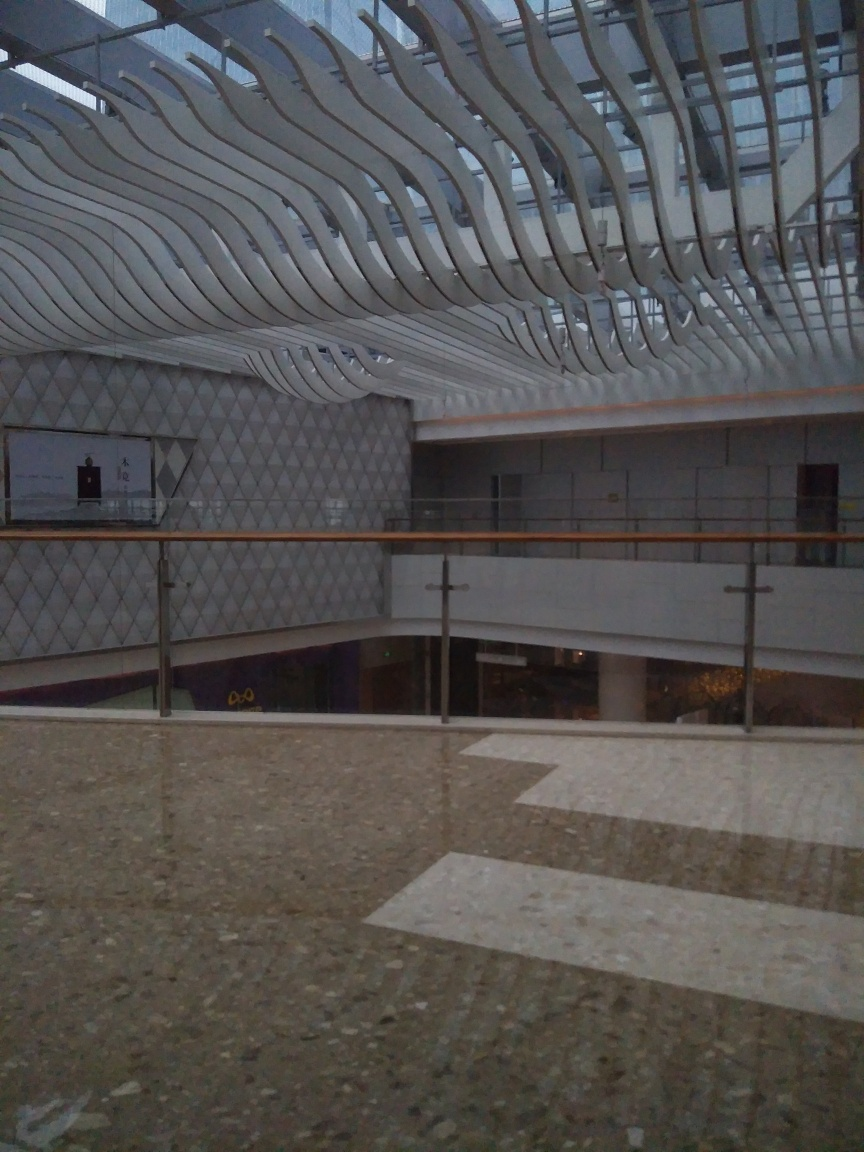What is the architectural style shown in the image? The architectural style in the image showcases elements of contemporary design, emphasizing geometric patterns and fluid forms. The use of repeated elements and curves is reminiscent of Modernism's fascination with new materials and techniques, while the blend of aesthetics and functionality suggests a postmodern influence. The design is sleek, employing metallic and textured finishes that reflect industrial and technology-influenced themes prevalent in 21st-century architecture. 